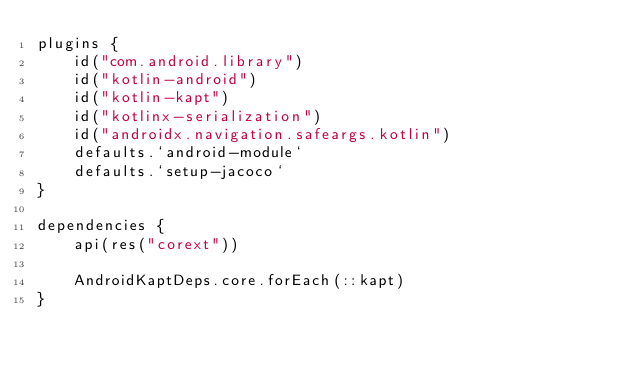<code> <loc_0><loc_0><loc_500><loc_500><_Kotlin_>plugins {
    id("com.android.library")
    id("kotlin-android")
    id("kotlin-kapt")
    id("kotlinx-serialization")
    id("androidx.navigation.safeargs.kotlin")
    defaults.`android-module`
    defaults.`setup-jacoco`
}

dependencies {
    api(res("corext"))

    AndroidKaptDeps.core.forEach(::kapt)
}
</code> 